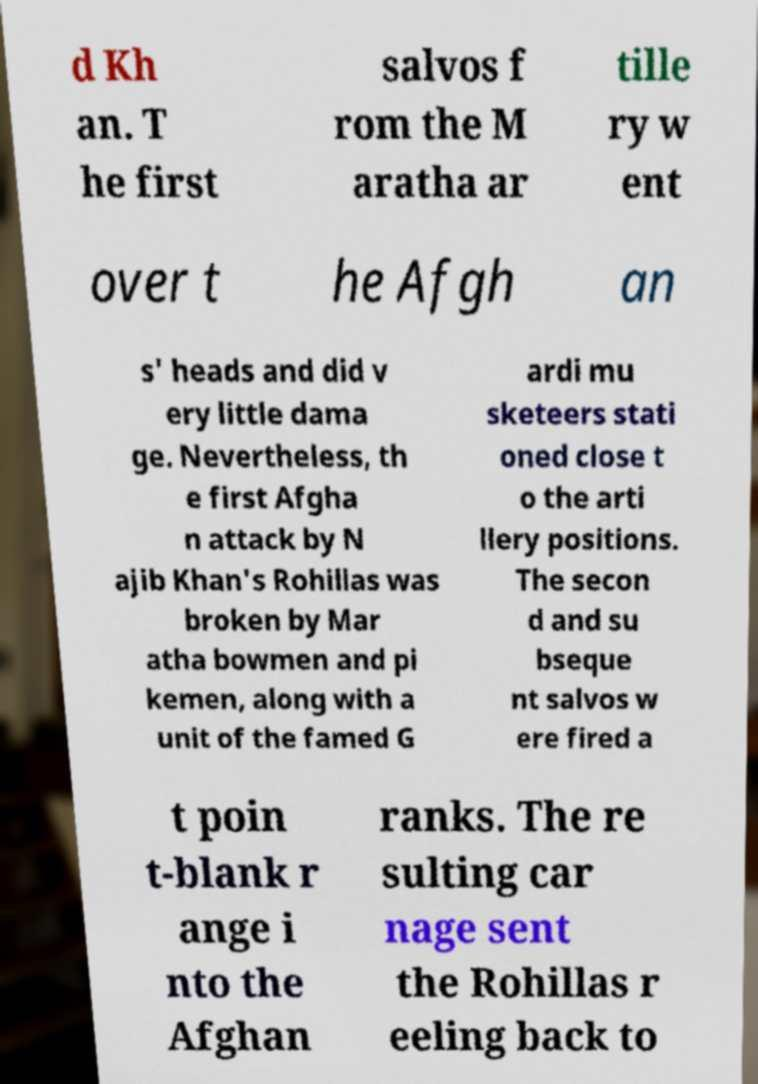I need the written content from this picture converted into text. Can you do that? d Kh an. T he first salvos f rom the M aratha ar tille ry w ent over t he Afgh an s' heads and did v ery little dama ge. Nevertheless, th e first Afgha n attack by N ajib Khan's Rohillas was broken by Mar atha bowmen and pi kemen, along with a unit of the famed G ardi mu sketeers stati oned close t o the arti llery positions. The secon d and su bseque nt salvos w ere fired a t poin t-blank r ange i nto the Afghan ranks. The re sulting car nage sent the Rohillas r eeling back to 